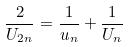Convert formula to latex. <formula><loc_0><loc_0><loc_500><loc_500>\frac { 2 } { U _ { 2 n } } = \frac { 1 } { u _ { n } } + \frac { 1 } { U _ { n } }</formula> 